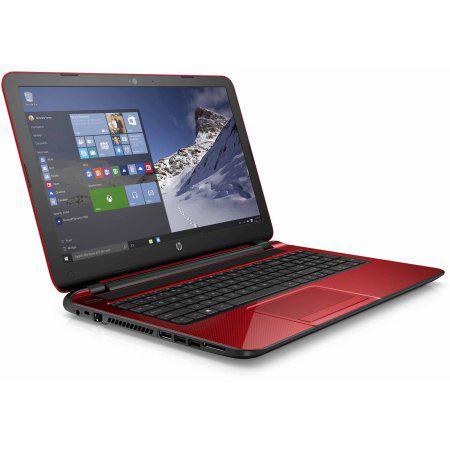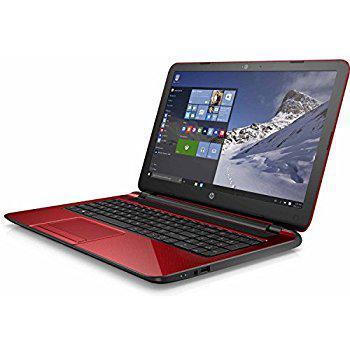The first image is the image on the left, the second image is the image on the right. For the images displayed, is the sentence "The full back of the red laptop is being shown." factually correct? Answer yes or no. No. The first image is the image on the left, the second image is the image on the right. For the images shown, is this caption "One of the laptops is turned so the screen is visible, and the other is turned so that the screen is not visible." true? Answer yes or no. No. 